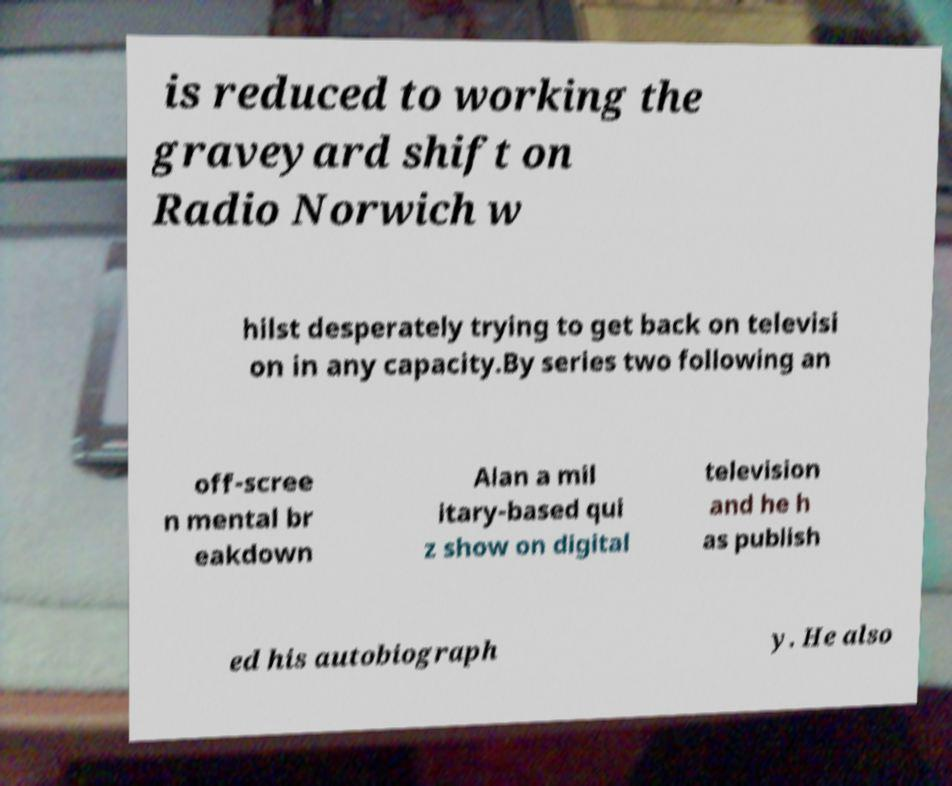What messages or text are displayed in this image? I need them in a readable, typed format. is reduced to working the graveyard shift on Radio Norwich w hilst desperately trying to get back on televisi on in any capacity.By series two following an off-scree n mental br eakdown Alan a mil itary-based qui z show on digital television and he h as publish ed his autobiograph y. He also 